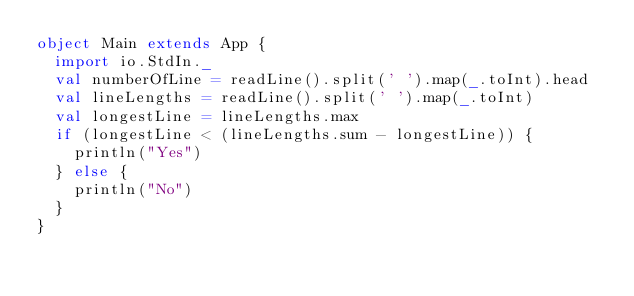Convert code to text. <code><loc_0><loc_0><loc_500><loc_500><_Scala_>object Main extends App {
  import io.StdIn._
  val numberOfLine = readLine().split(' ').map(_.toInt).head
  val lineLengths = readLine().split(' ').map(_.toInt)
  val longestLine = lineLengths.max
  if (longestLine < (lineLengths.sum - longestLine)) {
    println("Yes")
  } else {
    println("No")
  }
}</code> 